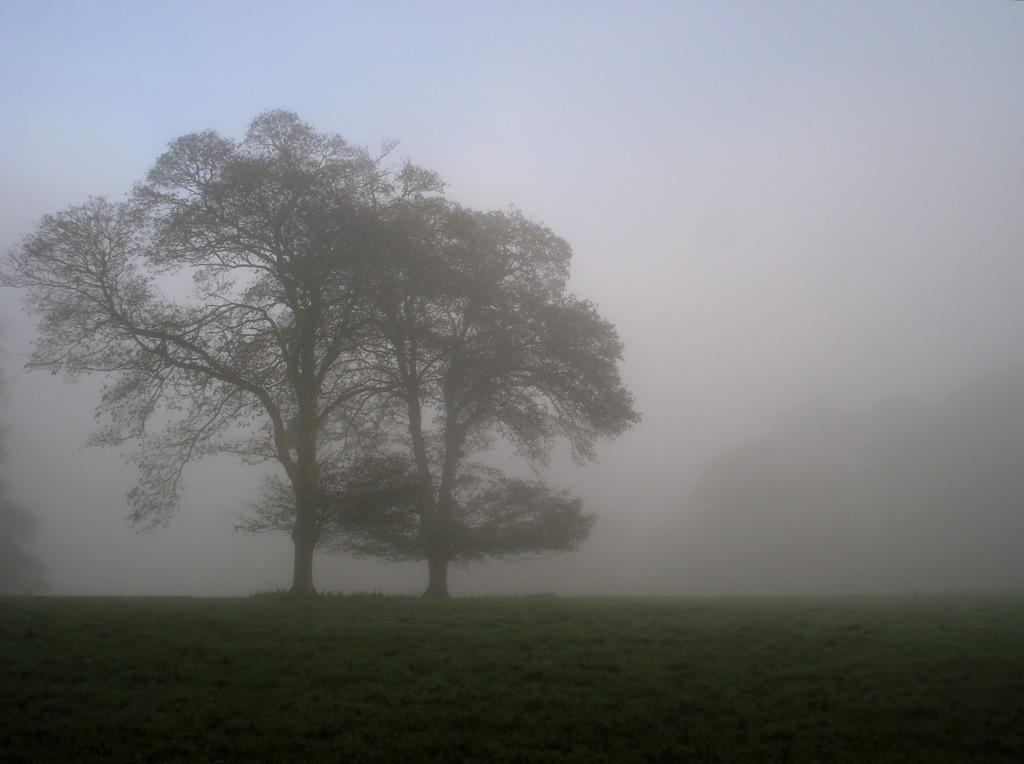What type of vegetation can be seen in the image? There are trees in the image. What atmospheric condition is present in the image? There is fog visible in the image. What type of ground cover is present in the image? There is grass in the image. What type of cushion is placed on the blade in the image? There is no cushion or blade present in the image; it features trees and fog. 